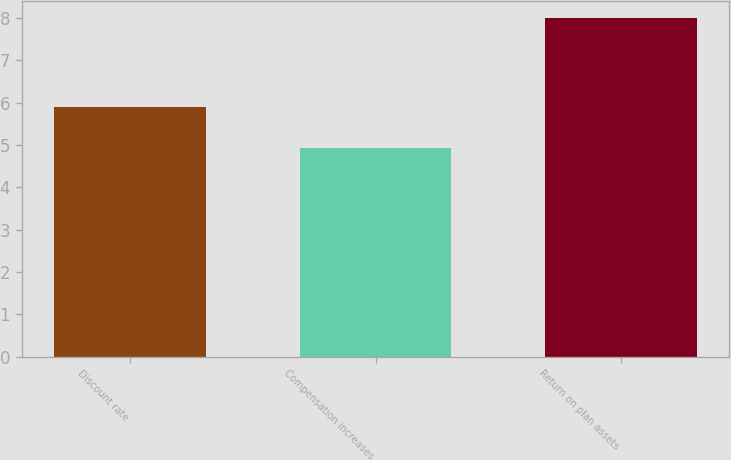Convert chart to OTSL. <chart><loc_0><loc_0><loc_500><loc_500><bar_chart><fcel>Discount rate<fcel>Compensation increases<fcel>Return on plan assets<nl><fcel>5.89<fcel>4.93<fcel>8<nl></chart> 